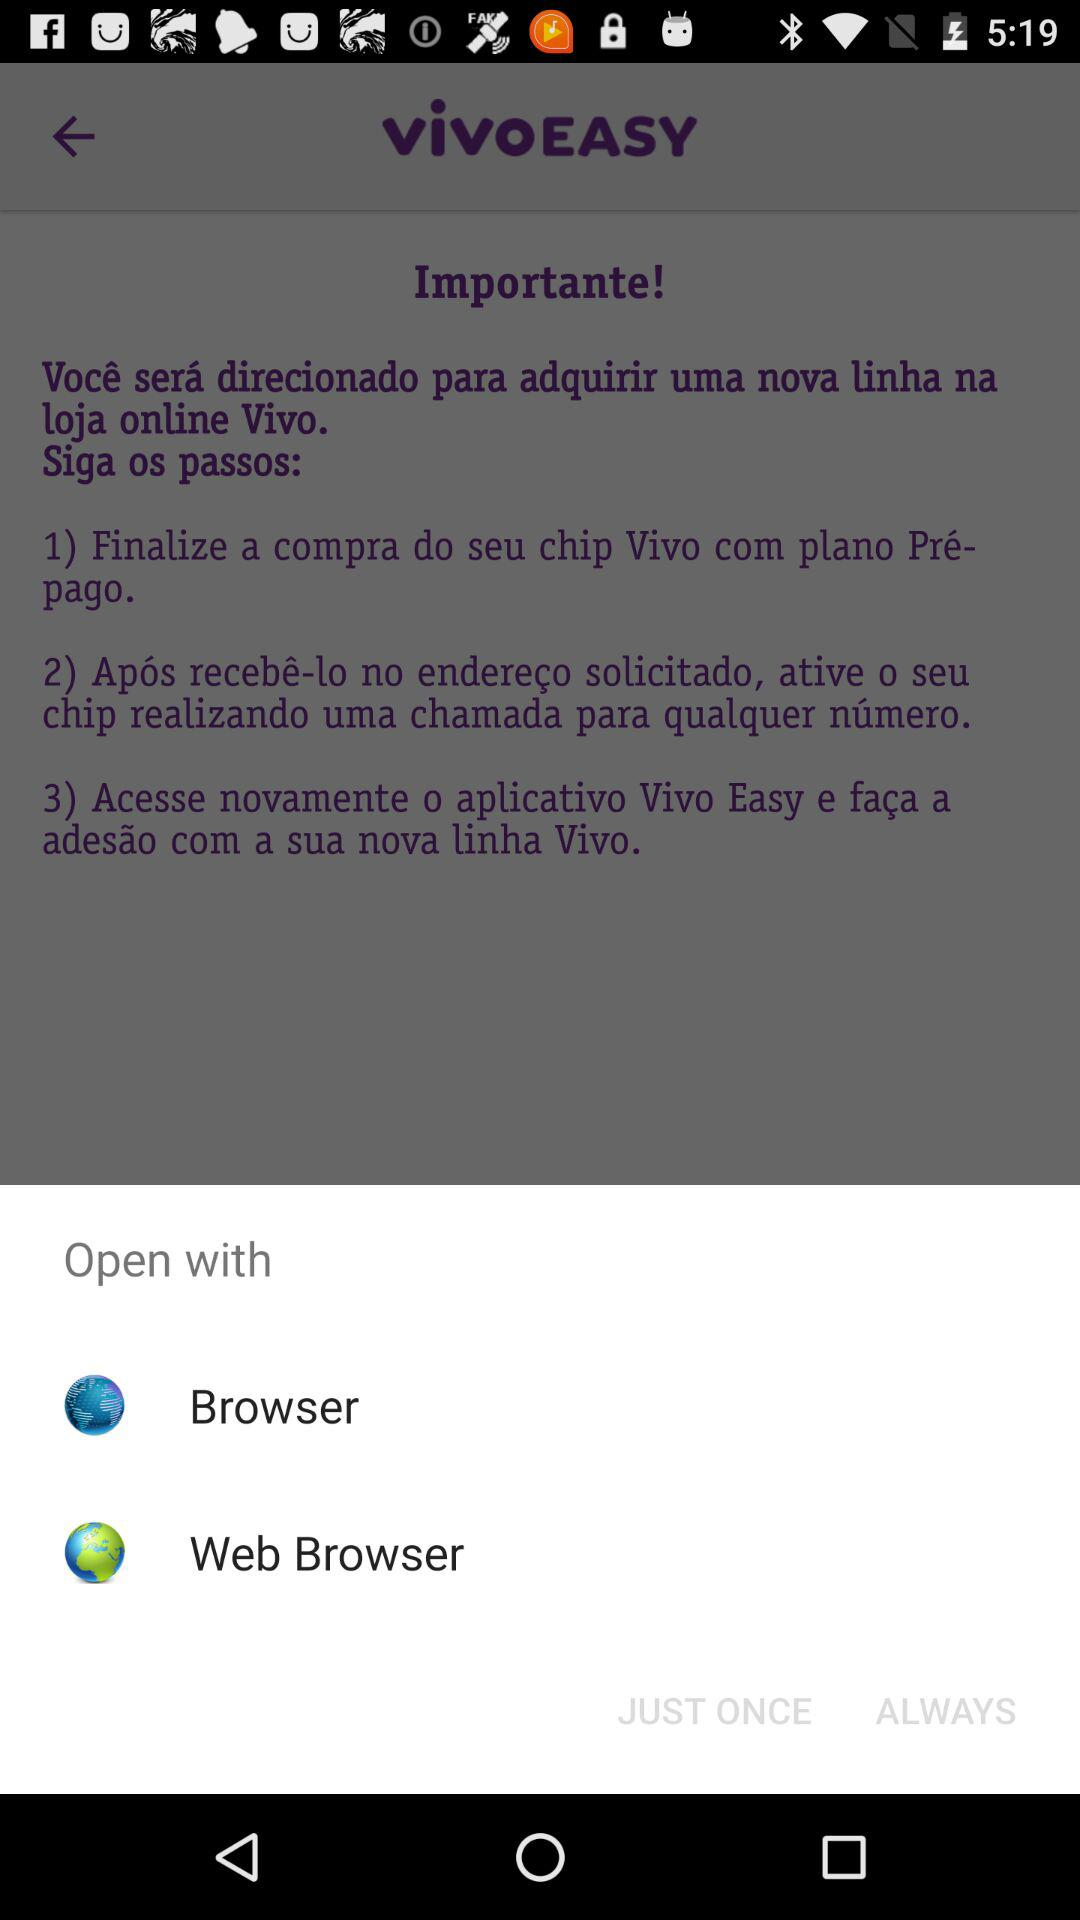How many steps are there in the process?
Answer the question using a single word or phrase. 3 